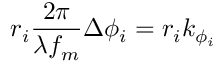Convert formula to latex. <formula><loc_0><loc_0><loc_500><loc_500>r _ { i } \frac { 2 \pi } { \lambda { f _ { m } } } \Delta { \phi } _ { i } = r _ { i } k _ { \phi _ { i } }</formula> 